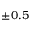<formula> <loc_0><loc_0><loc_500><loc_500>\pm 0 . 5 \AA</formula> 